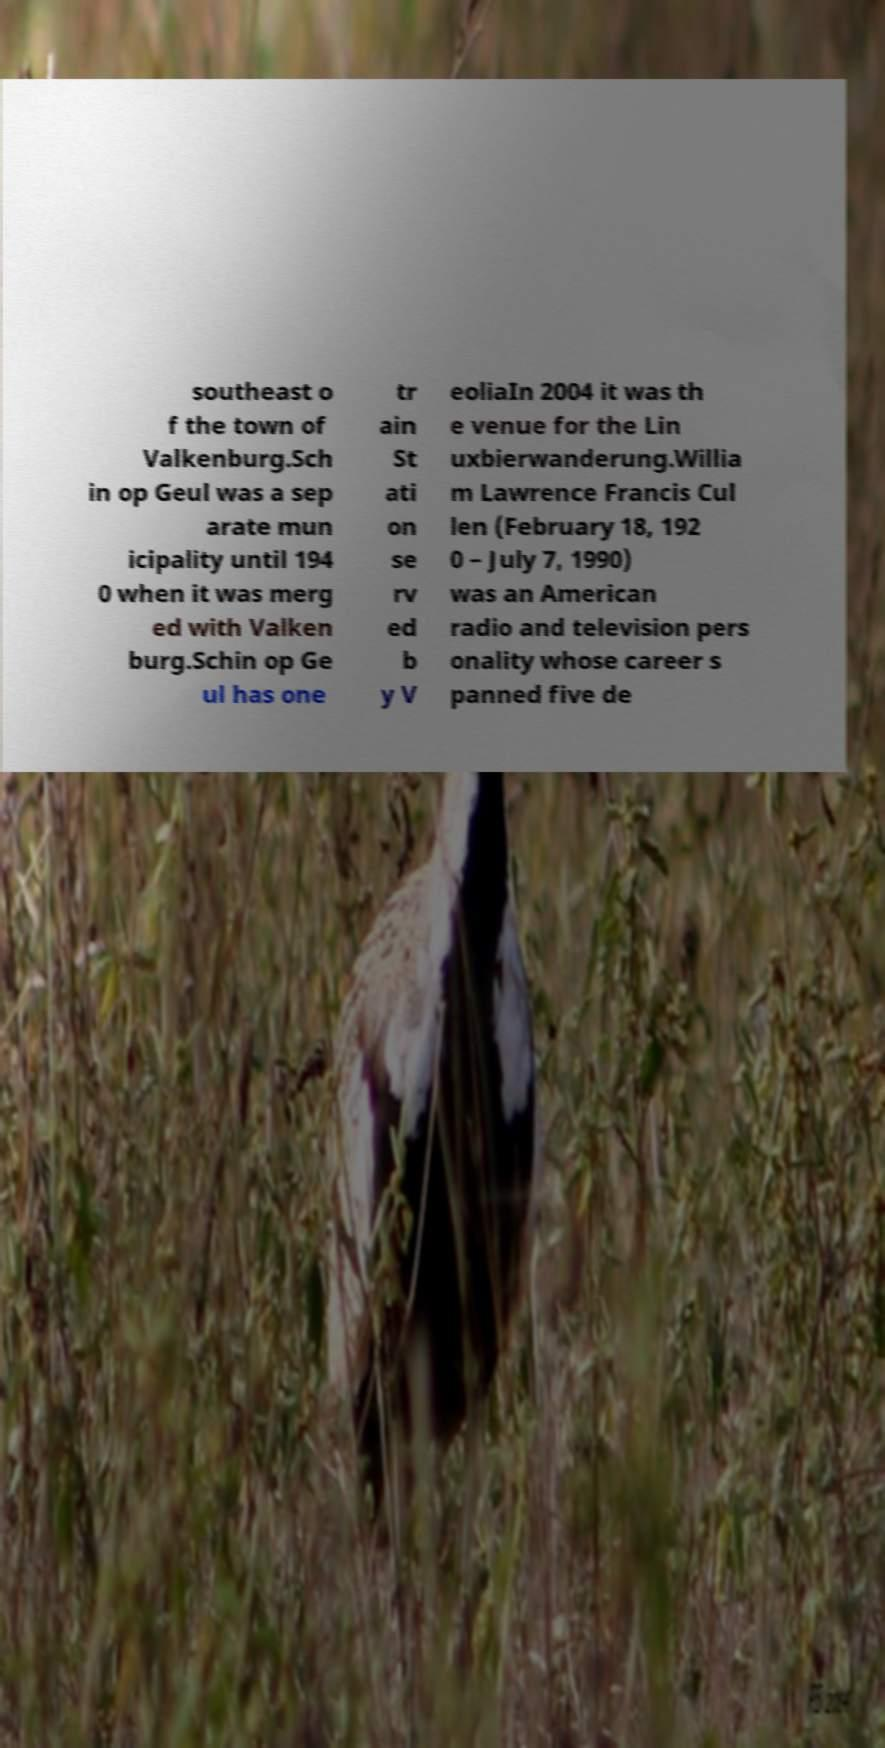There's text embedded in this image that I need extracted. Can you transcribe it verbatim? southeast o f the town of Valkenburg.Sch in op Geul was a sep arate mun icipality until 194 0 when it was merg ed with Valken burg.Schin op Ge ul has one tr ain St ati on se rv ed b y V eoliaIn 2004 it was th e venue for the Lin uxbierwanderung.Willia m Lawrence Francis Cul len (February 18, 192 0 – July 7, 1990) was an American radio and television pers onality whose career s panned five de 